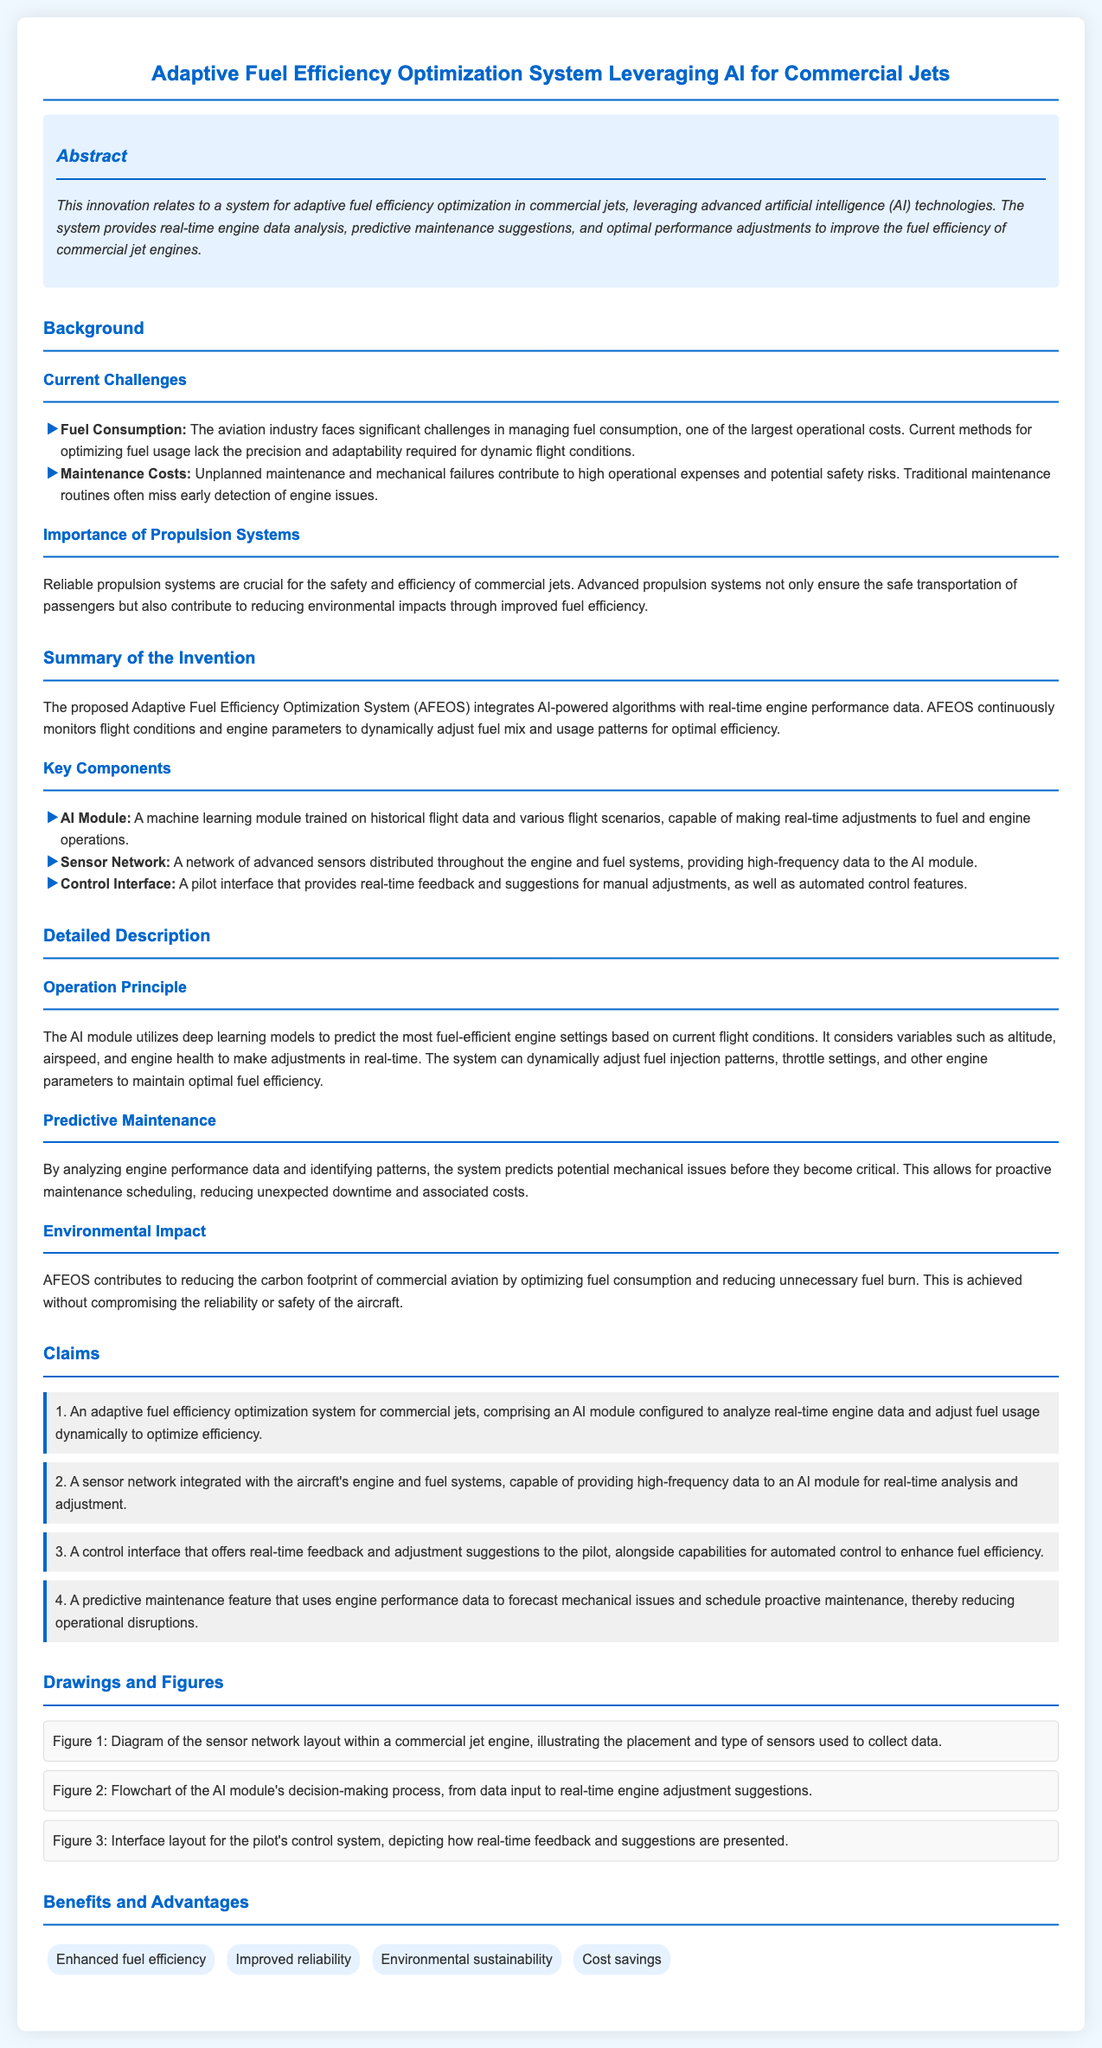What is the title of the patent application? The title of the patent application is provided in the document header, specifying the subject of the innovation.
Answer: Adaptive Fuel Efficiency Optimization System Leveraging AI for Commercial Jets What type of technologies does the system leverage? The document mentions the technologies leveraged by the system in the abstract section, highlighting the core feature of the innovation.
Answer: Advanced artificial intelligence (AI) What is one of the key components of the proposed system? Key components are listed in the summary of the invention, specifying the main parts that make up the adaptive fuel efficiency optimization system.
Answer: AI Module What does the AI module utilize to predict fuel-efficient settings? The operation principle section describes what the AI module relies on for its predictions regarding engine settings.
Answer: Deep learning models What is one benefit of the Adaptive Fuel Efficiency Optimization System? Benefits are outlined in a dedicated section, summarizing the advantages of implementing the system in commercial aviation.
Answer: Enhanced fuel efficiency What current challenge is related to fuel consumption? The background section identifies specific challenges in the aviation industry concerning fuel management, stating why the innovation is necessary.
Answer: Lack of precision and adaptability How does the system contribute to environmental sustainability? The document touches on the environmental impact of the system in its detailed description, linking optimization to reduced ecological footprint.
Answer: Reducing unnecessary fuel burn What is the purpose of the predictive maintenance feature? The claims section indicates the purpose of the predictive maintenance feature, stating its role in the overall functionality of the system.
Answer: To forecast mechanical issues and schedule proactive maintenance 